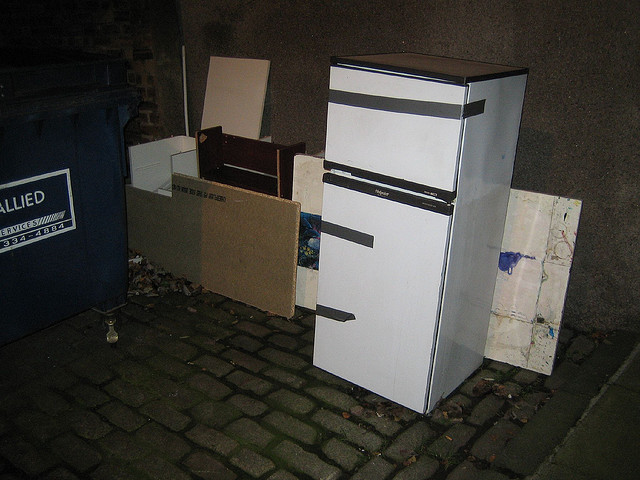<image>What is behind the refrigerators? I don't know what is behind the refrigerators. It can be drawings, boards, furniture, or a wall. Where are packing boxes? I don't know where the packing boxes are located. It can be on left or against wall or beside refrigerator. Is there food in the fridge? No, there is no food in the fridge. What is behind the refrigerators? I don't know what is behind the refrigerators. It can be drawings, boards, furniture, or a wall. Where are packing boxes? I don't know where the packing boxes are. It can be seen on the left, to the left of the refrigerator, against the wall, beside the refrigerator, or all around. Is there food in the fridge? I don't know if there is food in the fridge. It can be seen that there is no food. 